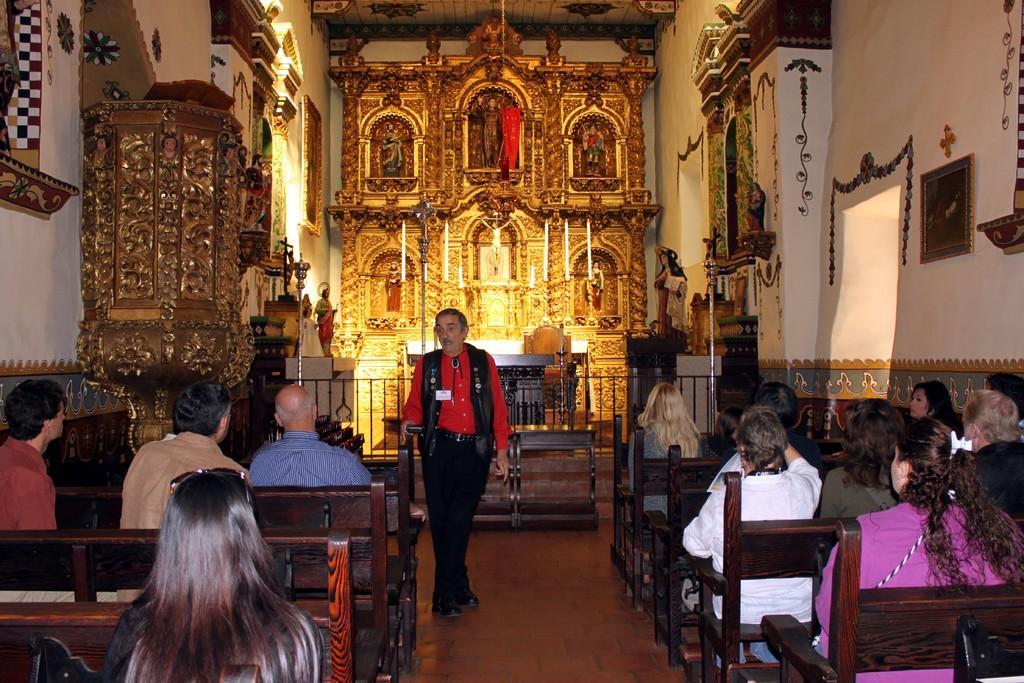How would you summarize this image in a sentence or two? This is the picture of a church , where there are group of people sitting at the left side , group of people sitting at the right side there are sculptures , statues and photo frames attached to the wall. 